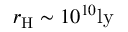<formula> <loc_0><loc_0><loc_500><loc_500>r _ { H } \sim 1 0 ^ { 1 0 } l y</formula> 